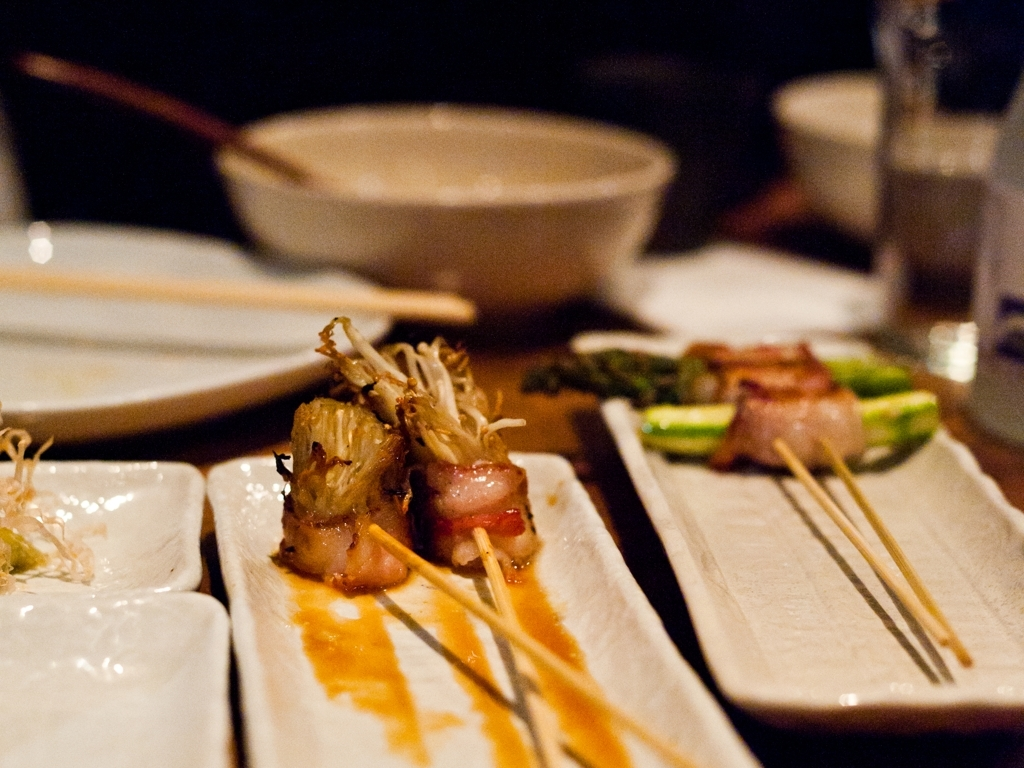What does the setting tell us about the dining experience? The dimly lit, intimate setting with elegant tableware suggests a fine dining experience. The use of chopsticks and shared plates indicates a communal eating style, which is common in some Asian dining settings. What mood does the image evoke with its lighting and composition? The soft, warm lighting and the close-up composition of the dishes convey a sense of coziness and exclusivity. It evokes an atmosphere that is both sophisticated and inviting, encouraging diners to savor each bite and enjoy the company. 